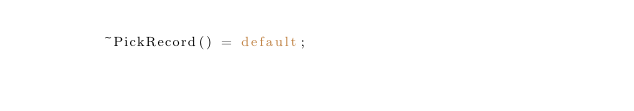<code> <loc_0><loc_0><loc_500><loc_500><_C_>        ~PickRecord() = default;
</code> 